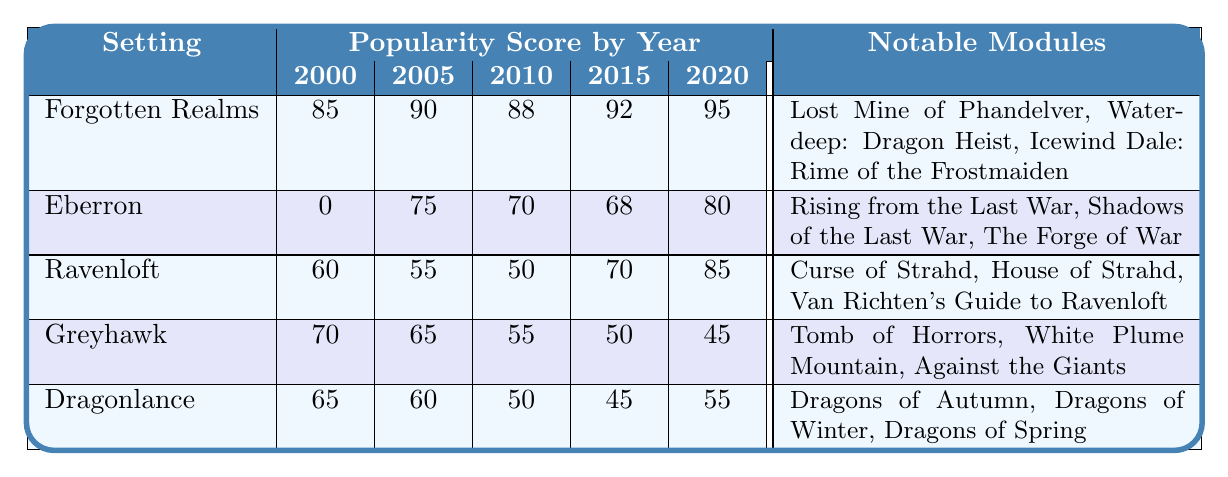What is the popularity score of the Forgotten Realms in 2010? The table shows that the popularity score for the Forgotten Realms in 2010 is listed next to the year 2010 in the corresponding row, which is 88.
Answer: 88 In which year did Eberron achieve its highest popularity score? By examining the popularity scores year by year for Eberron, we can see that the highest score of 80 is in the year 2020.
Answer: 2020 What is the difference in popularity score between Ravenloft in 2000 and in 2020? The score for Ravenloft in 2000 is 60 and in 2020 it is 85. The difference is calculated by subtracting 60 from 85, which gives us 25.
Answer: 25 Which campaign setting had the lowest popularity score in 2000? Looking at the table for the year 2000, Eberron has a score of 0, which is the lowest compared to the other settings that year.
Answer: Eberron What was the average popularity score of Dragonlance over the years provided? The scores for Dragonlance from 2000 to 2020 are 65, 60, 50, 45, and 55. First, we sum these scores: 65 + 60 + 50 + 45 + 55 = 275. Then divide by the number of years (5) to get the average: 275 / 5 = 55.
Answer: 55 Was there a year where Greyhawk had a higher popularity score than Eberron? By examining the scores, Greyhawk had scores of 70, 65, 55, 50, and 45, while Eberron had 0, 75, 70, 68, and 80. Looking at their scores for each year, we see that Greyhawk was higher than Eberron only in the year 2000, as it scored 70 while Eberron scored 0.
Answer: Yes In which year did Ravenloft's popularity score show the most significant increase? Looking at Ravenloft's scores: 60 (2000), 55 (2005), 50 (2010), 70 (2015), and 85 (2020). The largest increase is from 50 in 2010 to 70 in 2015, which is 20 points. However, the increase from 70 in 2015 to 85 in 2020 is another increase of 15 points. Since 20 is more than 15, the highest increase occurred between 2010 and 2015.
Answer: 2010 to 2015 Which setting had the most notable modules listed? By reviewing the notable modules listed for each setting, Forgotten Realms has three: "Lost Mine of Phandelver," "Waterdeep: Dragon Heist," and "Icewind Dale: Rime of the Frostmaiden." All other settings also have three notable modules listed. The most notable modules are equal among settings.
Answer: Equal among settings 